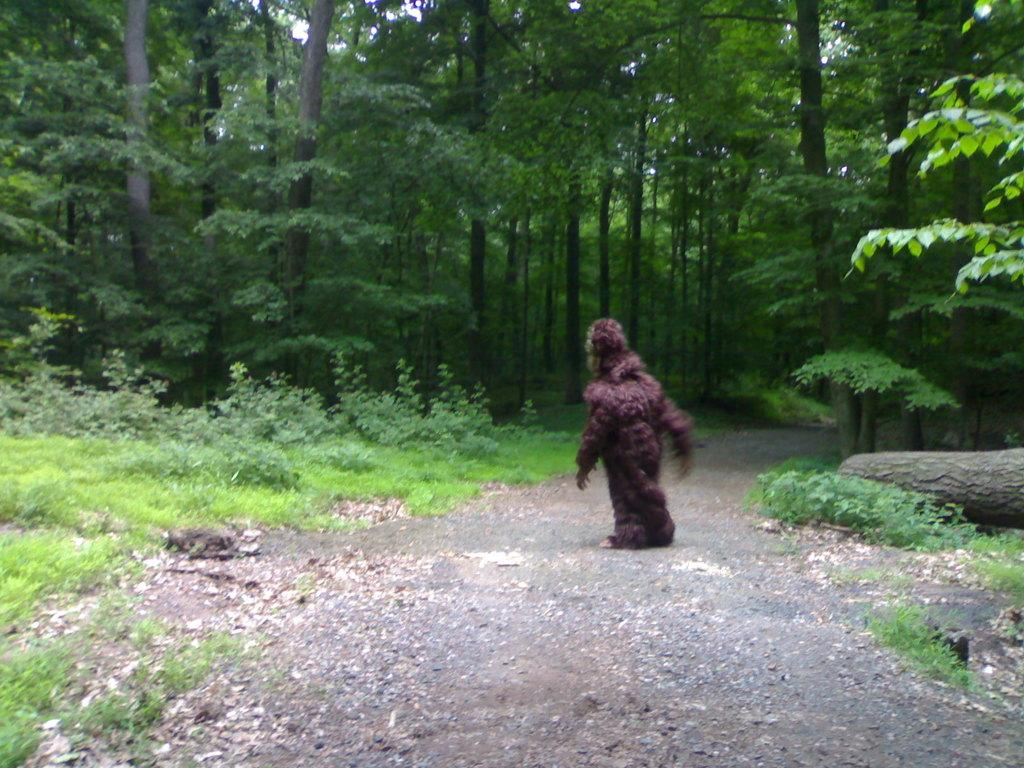What is the person in the image wearing? The person is wearing an animal costume in the image. What type of terrain is visible in the image? There is grass visible in the image. What object can be seen in the image besides the person and grass? There is a wooden log in the image. What can be seen in the background of the image? There are many trees and the sky visible in the background of the image. What type of circle is present in the image? There is no circle present in the image. 